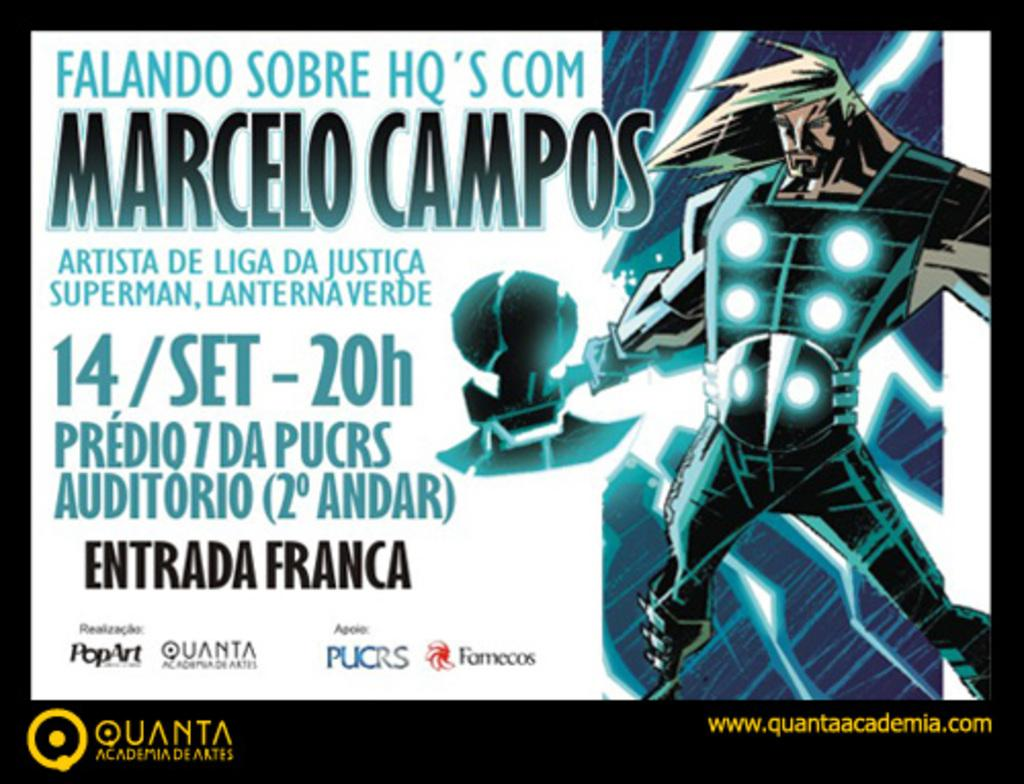Provide a one-sentence caption for the provided image. A drawing of Thor stands next to an ad for Quanta, displaying the dates for an event. 